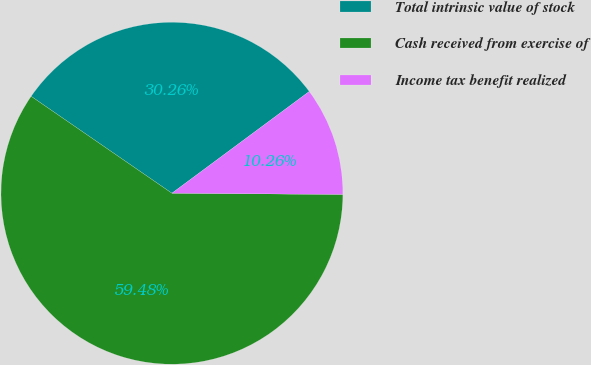Convert chart to OTSL. <chart><loc_0><loc_0><loc_500><loc_500><pie_chart><fcel>Total intrinsic value of stock<fcel>Cash received from exercise of<fcel>Income tax benefit realized<nl><fcel>30.26%<fcel>59.49%<fcel>10.26%<nl></chart> 